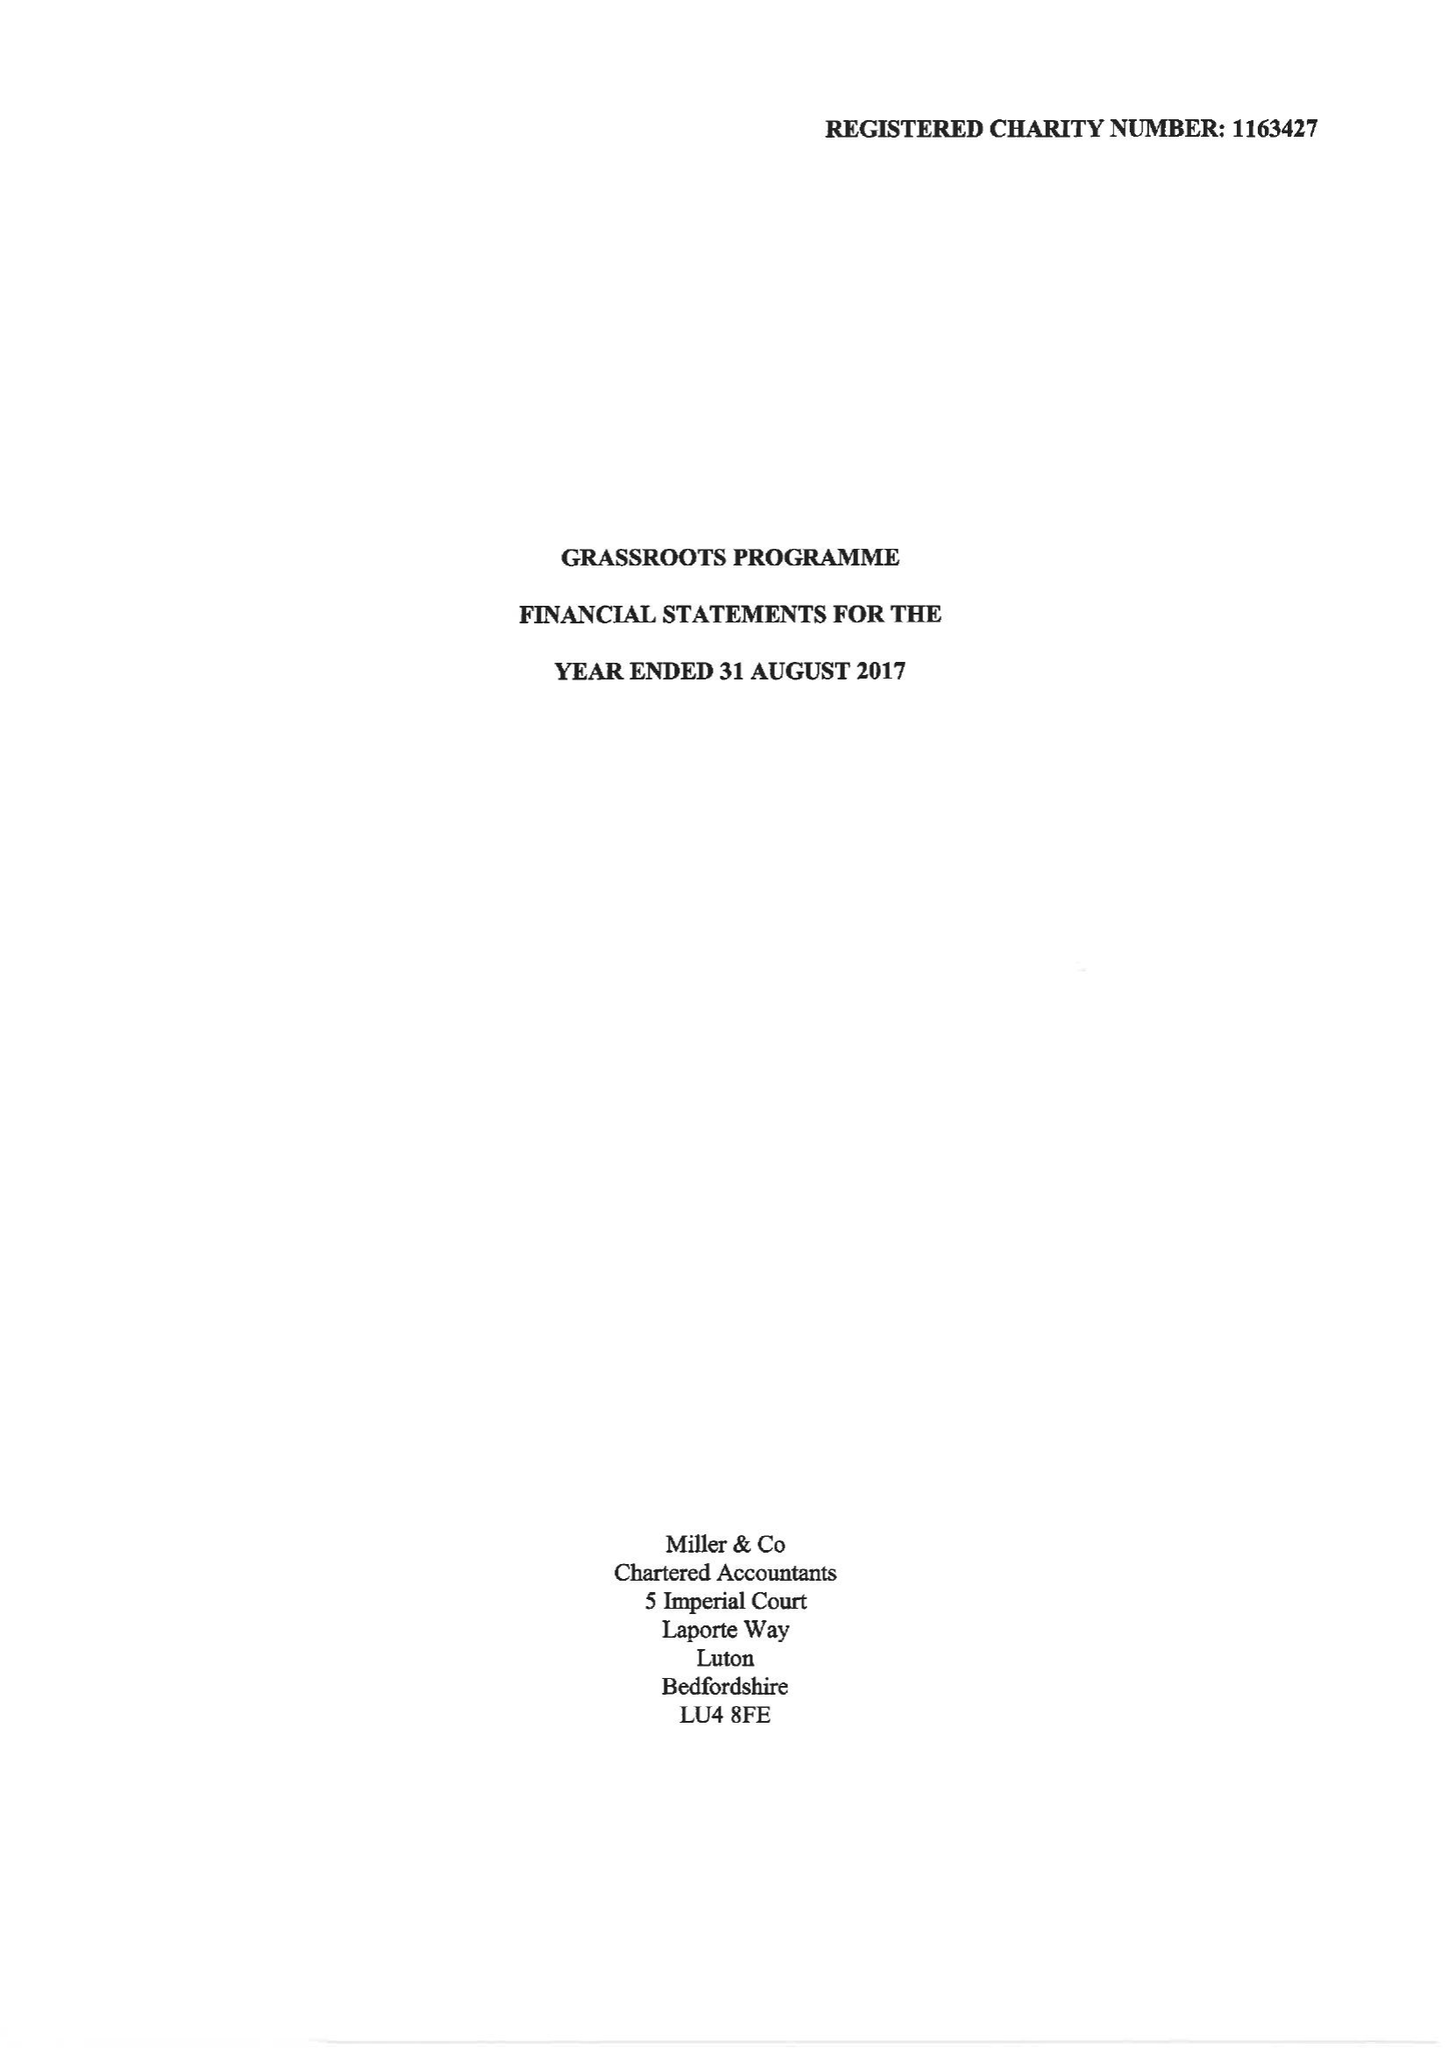What is the value for the income_annually_in_british_pounds?
Answer the question using a single word or phrase. 181248.00 